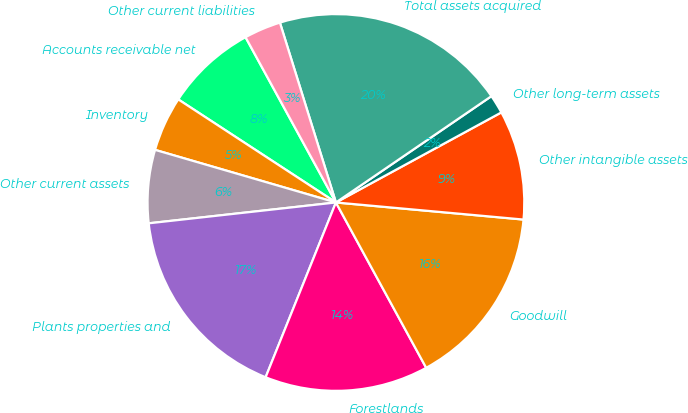Convert chart to OTSL. <chart><loc_0><loc_0><loc_500><loc_500><pie_chart><fcel>Accounts receivable net<fcel>Inventory<fcel>Other current assets<fcel>Plants properties and<fcel>Forestlands<fcel>Goodwill<fcel>Other intangible assets<fcel>Other long-term assets<fcel>Total assets acquired<fcel>Other current liabilities<nl><fcel>7.82%<fcel>4.71%<fcel>6.27%<fcel>17.15%<fcel>14.04%<fcel>15.6%<fcel>9.38%<fcel>1.61%<fcel>20.26%<fcel>3.16%<nl></chart> 